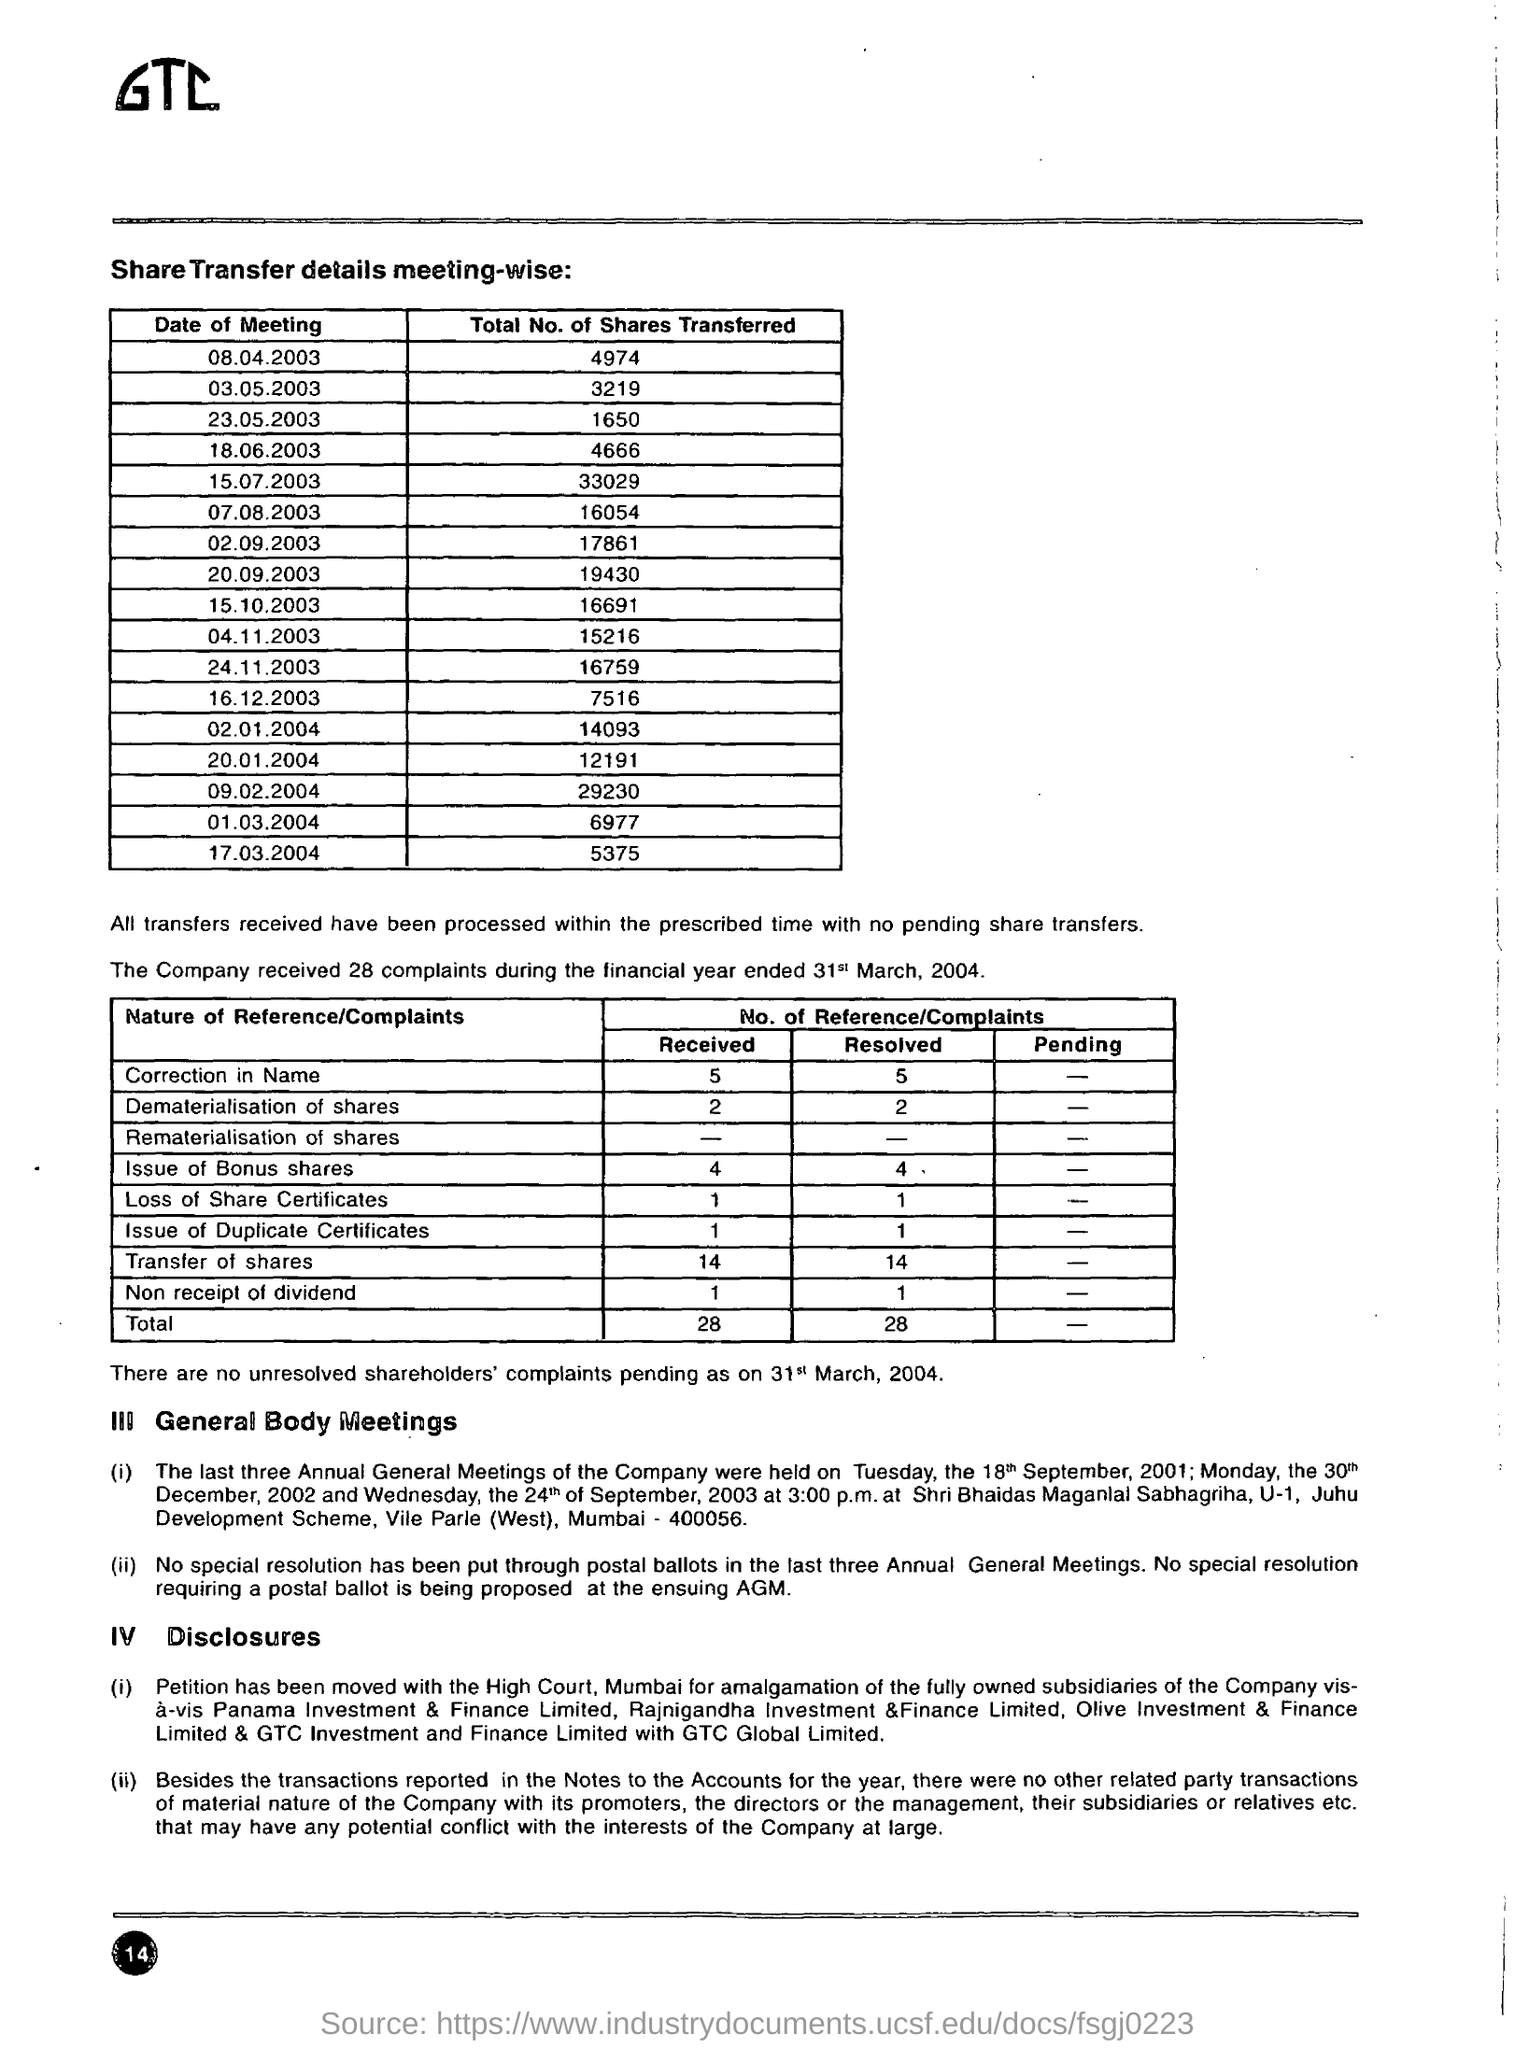What is the total no .of shares transferred on 08.04.2003?
Give a very brief answer. 4974. What is the total no .of shares transferred on 17.03.2004?
Keep it short and to the point. 5375. How many complaints a company received during the financial year ended 31st march , 2004
Provide a succinct answer. 28. What is the total no of reference / complaints received ?
Provide a short and direct response. 28. What is the total no of reference / complaints resolved  ?
Offer a very short reply. 28. What is the total no of reference / complaints resolved in correction in name ? ?
Offer a very short reply. 5. How many  total no of shares are transferred  on date of meeting 23.05.2003?
Offer a terse response. 1650. What is the total no .of shares transferred on 20.01.2004
Offer a terse response. 12191. 